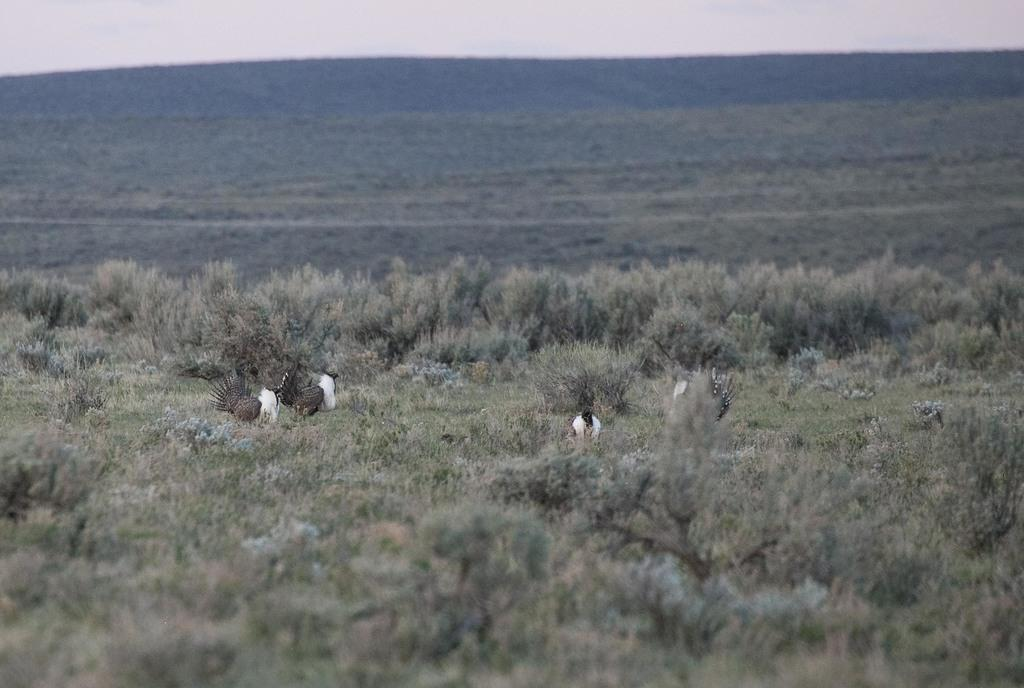What is located in the center of the image? There are birds in the center of the image. What type of vegetation is at the bottom of the image? There is grass at the bottom of the image. What can be seen in the background of the image? There is a hill and the sky visible in the background of the image. How much money is being taught by the birds in the image? There is no money or teaching present in the image; it features birds, grass, a hill, and the sky. What type of knot is being used by the birds to fly in the image? Birds do not use knots to fly; they have wings that enable them to fly. 